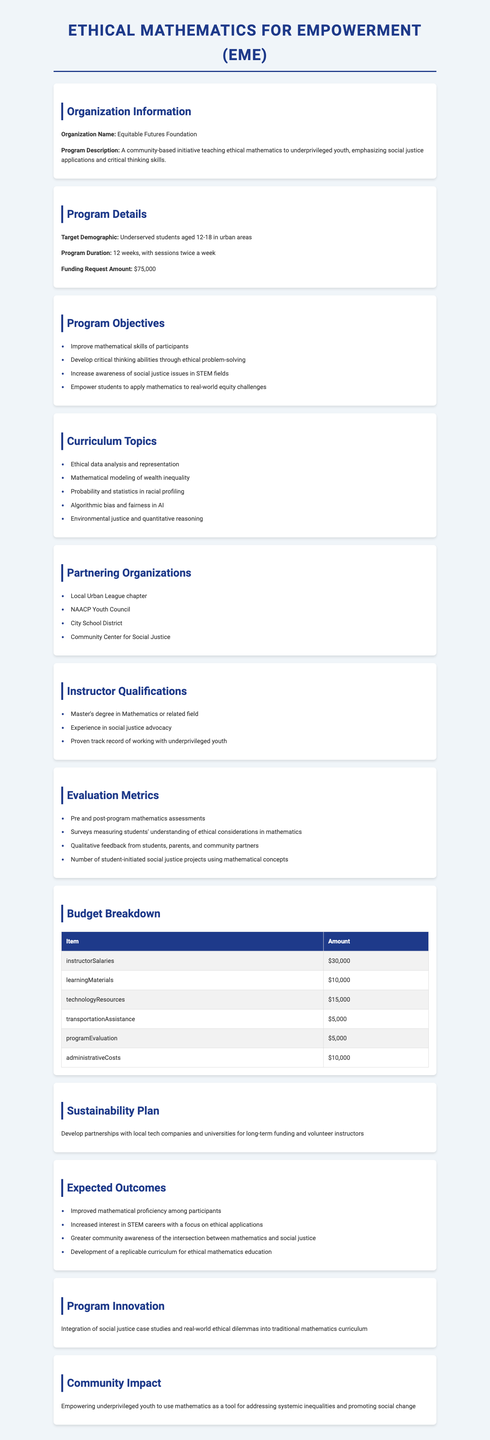What is the title of the grant? The title of the grant is presented at the top of the document.
Answer: Ethical Mathematics for Empowerment (EME) What is the amount of funding requested? The funding request amount is clearly noted in the document.
Answer: $75,000 Who is the target demographic for the program? The target demographic is specified in the program details section.
Answer: Underserved students aged 12-18 in urban areas How long is the program designed to run? The duration of the program is stated in the program details section of the document.
Answer: 12 weeks What are the instructor qualifications required? The qualifications for instructors are listed in a specific section of the document.
Answer: Master's degree in Mathematics or related field What is one expected outcome of the program? One of the expected outcomes is mentioned in the corresponding section of the document.
Answer: Improved mathematical proficiency among participants What is the program innovation? The program innovation refers to a unique aspect of the curriculum outlined in the document.
Answer: Integration of social justice case studies and real-world ethical dilemmas into traditional mathematics curriculum Which organization is partnered with the program? Partnering organizations are listed in a dedicated section within the document.
Answer: Local Urban League chapter What evaluation metric will measure students’ understanding of ethical considerations? The evaluation metrics section specifies how student understanding will be assessed.
Answer: Surveys measuring students' understanding of ethical considerations in mathematics 